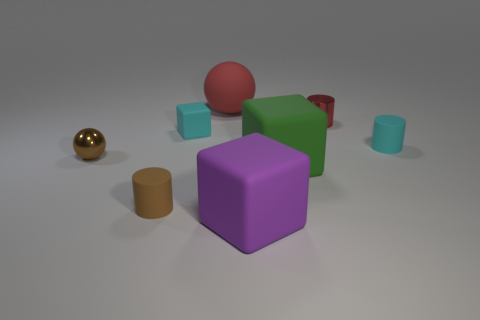Add 2 large purple shiny things. How many objects exist? 10 Subtract all spheres. How many objects are left? 6 Subtract all brown objects. Subtract all balls. How many objects are left? 4 Add 3 red matte balls. How many red matte balls are left? 4 Add 5 small gray shiny objects. How many small gray shiny objects exist? 5 Subtract 0 green spheres. How many objects are left? 8 